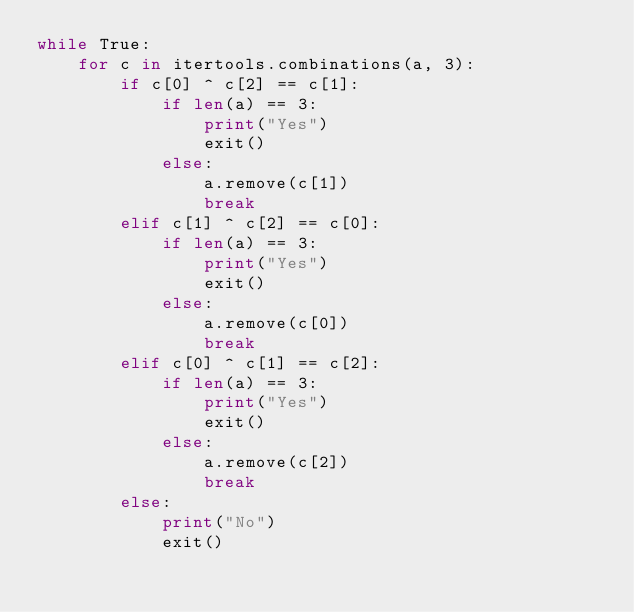<code> <loc_0><loc_0><loc_500><loc_500><_Python_>while True:
    for c in itertools.combinations(a, 3):
        if c[0] ^ c[2] == c[1]:
            if len(a) == 3:
                print("Yes")
                exit()
            else:
                a.remove(c[1])
                break
        elif c[1] ^ c[2] == c[0]:
            if len(a) == 3:
                print("Yes")
                exit()
            else:
                a.remove(c[0])
                break
        elif c[0] ^ c[1] == c[2]:
            if len(a) == 3:
                print("Yes")
                exit()
            else:
                a.remove(c[2])
                break
        else:
            print("No")
            exit()</code> 